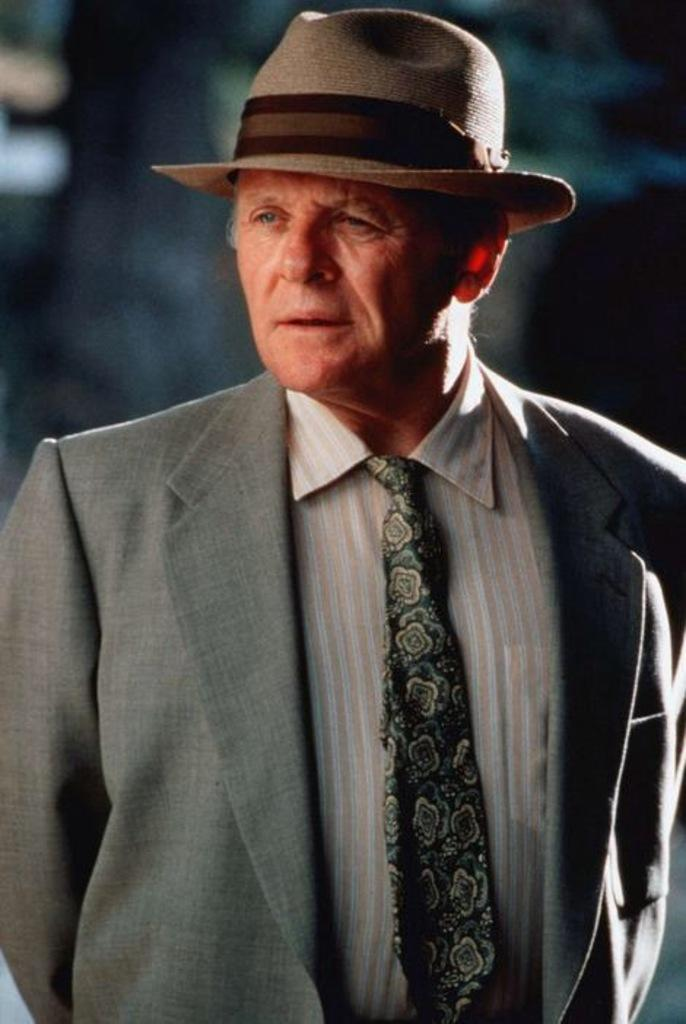Who is present in the image? There is a man in the image. What is the man doing in the image? The man is standing. What type of clothing is the man wearing in the image? The man is wearing a coat, a tie, and a hat. Can you describe the background of the image? The background of the image is blurred. What type of rice is being cooked in the image? There is no rice present in the image; it features a man standing while wearing a coat, tie, and hat. 